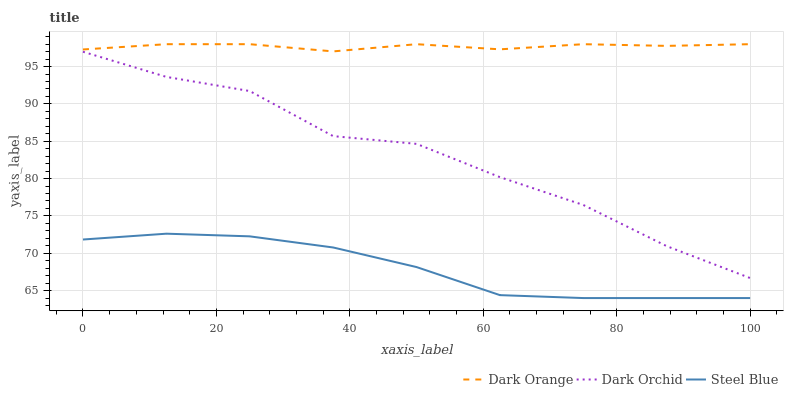Does Steel Blue have the minimum area under the curve?
Answer yes or no. Yes. Does Dark Orange have the maximum area under the curve?
Answer yes or no. Yes. Does Dark Orchid have the minimum area under the curve?
Answer yes or no. No. Does Dark Orchid have the maximum area under the curve?
Answer yes or no. No. Is Dark Orange the smoothest?
Answer yes or no. Yes. Is Dark Orchid the roughest?
Answer yes or no. Yes. Is Steel Blue the smoothest?
Answer yes or no. No. Is Steel Blue the roughest?
Answer yes or no. No. Does Dark Orchid have the lowest value?
Answer yes or no. No. Does Dark Orange have the highest value?
Answer yes or no. Yes. Does Dark Orchid have the highest value?
Answer yes or no. No. Is Dark Orchid less than Dark Orange?
Answer yes or no. Yes. Is Dark Orange greater than Dark Orchid?
Answer yes or no. Yes. Does Dark Orchid intersect Dark Orange?
Answer yes or no. No. 